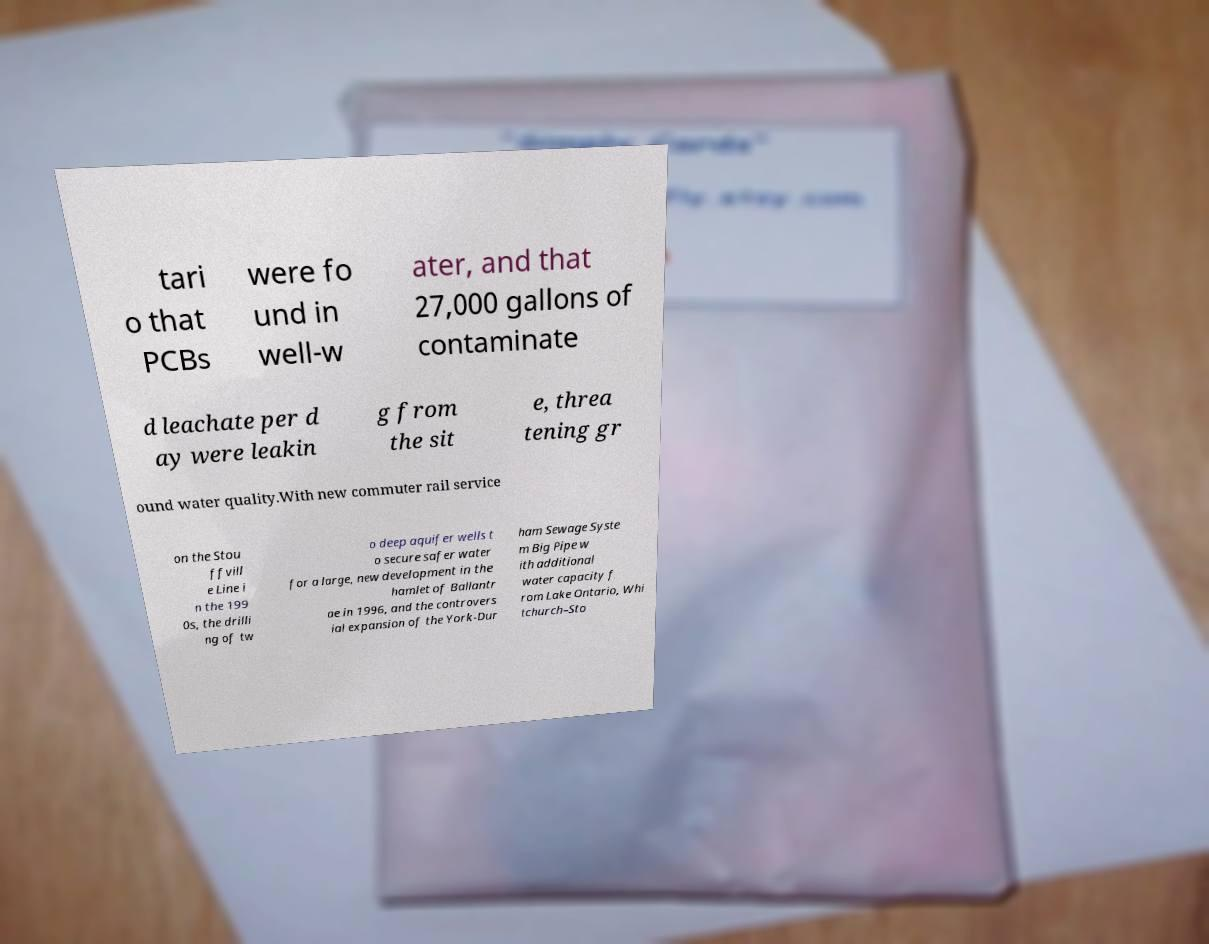Could you assist in decoding the text presented in this image and type it out clearly? tari o that PCBs were fo und in well-w ater, and that 27,000 gallons of contaminate d leachate per d ay were leakin g from the sit e, threa tening gr ound water quality.With new commuter rail service on the Stou ffvill e Line i n the 199 0s, the drilli ng of tw o deep aquifer wells t o secure safer water for a large, new development in the hamlet of Ballantr ae in 1996, and the controvers ial expansion of the York-Dur ham Sewage Syste m Big Pipe w ith additional water capacity f rom Lake Ontario, Whi tchurch–Sto 